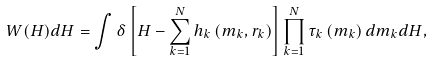<formula> <loc_0><loc_0><loc_500><loc_500>W ( H ) d H = \int \delta \left [ H - \sum ^ { N } _ { k = 1 } h _ { k } \left ( m _ { k } , r _ { k } \right ) \right ] \prod ^ { N } _ { k = 1 } \tau _ { k } \left ( m _ { k } \right ) d m _ { k } d H ,</formula> 